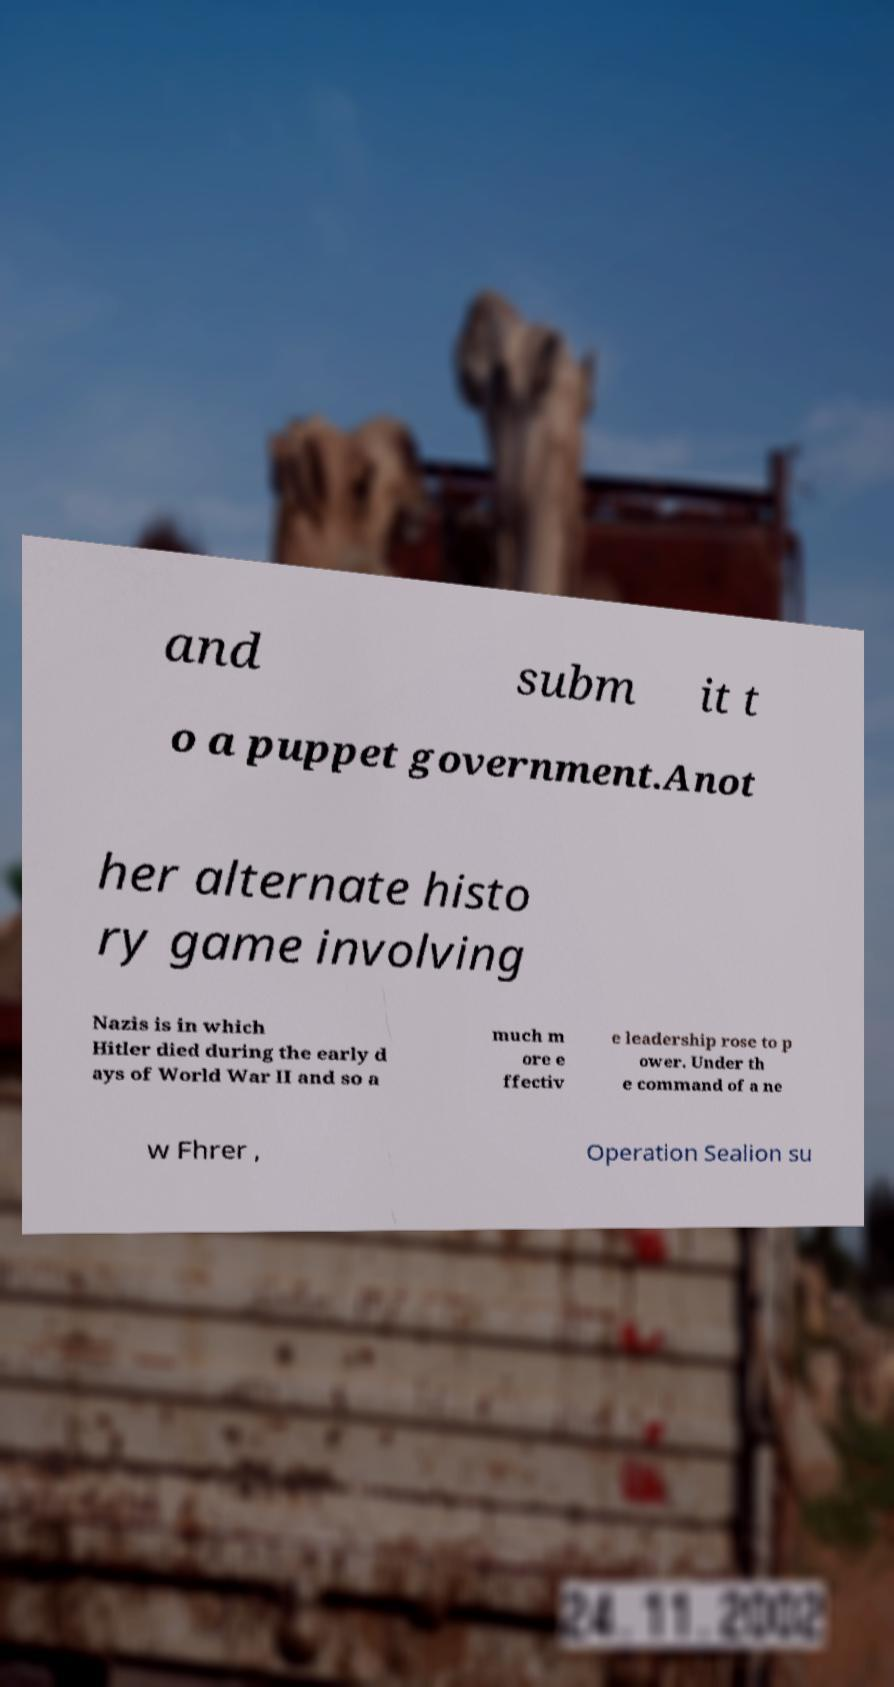Can you read and provide the text displayed in the image?This photo seems to have some interesting text. Can you extract and type it out for me? and subm it t o a puppet government.Anot her alternate histo ry game involving Nazis is in which Hitler died during the early d ays of World War II and so a much m ore e ffectiv e leadership rose to p ower. Under th e command of a ne w Fhrer , Operation Sealion su 